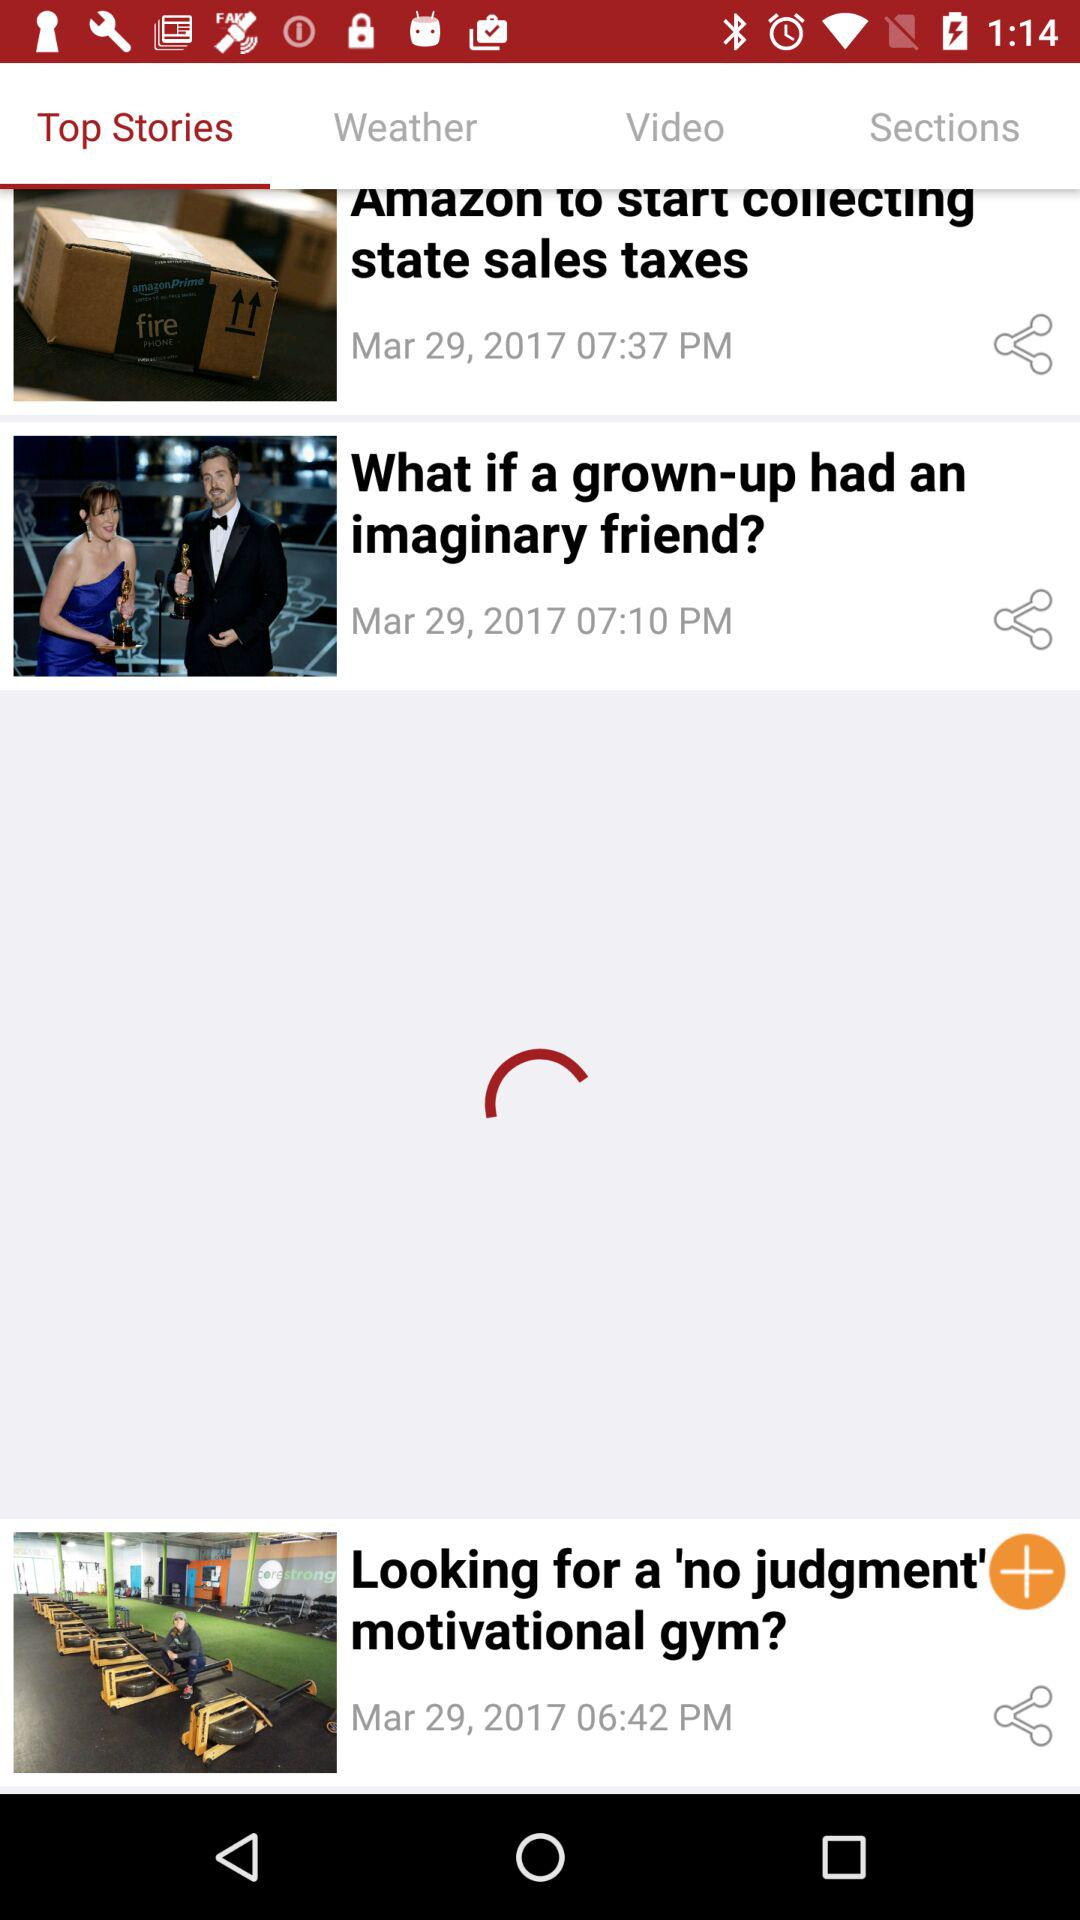How many stories are available?
Answer the question using a single word or phrase. 3 